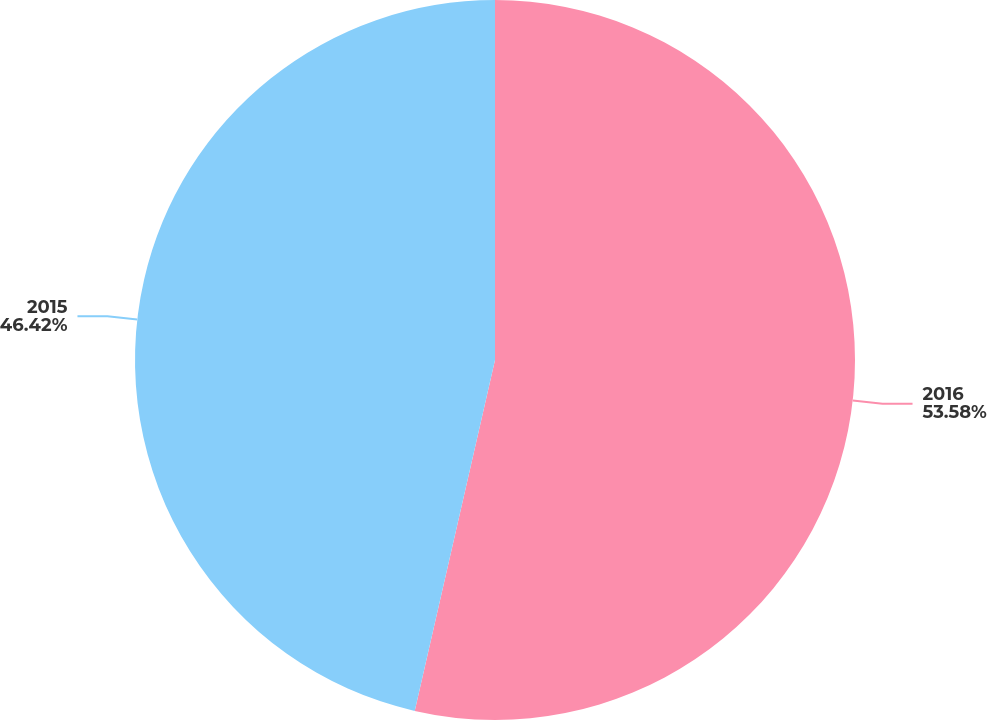<chart> <loc_0><loc_0><loc_500><loc_500><pie_chart><fcel>2016<fcel>2015<nl><fcel>53.58%<fcel>46.42%<nl></chart> 